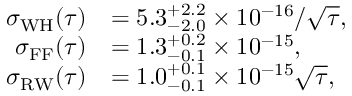Convert formula to latex. <formula><loc_0><loc_0><loc_500><loc_500>\begin{array} { r l } { \sigma _ { W H } ( \tau ) } & { = 5 . 3 _ { - 2 . 0 } ^ { + 2 . 2 } \times 1 0 ^ { - 1 6 } / \sqrt { \tau } , } \\ { \sigma _ { F F } ( \tau ) } & { = 1 . 3 _ { - 0 . 1 } ^ { + 0 . 2 } \times 1 0 ^ { - 1 5 } , } \\ { \sigma _ { R W } ( \tau ) } & { = 1 . 0 _ { - 0 . 1 } ^ { + 0 . 1 } \times 1 0 ^ { - 1 5 } \sqrt { \tau } , } \end{array}</formula> 